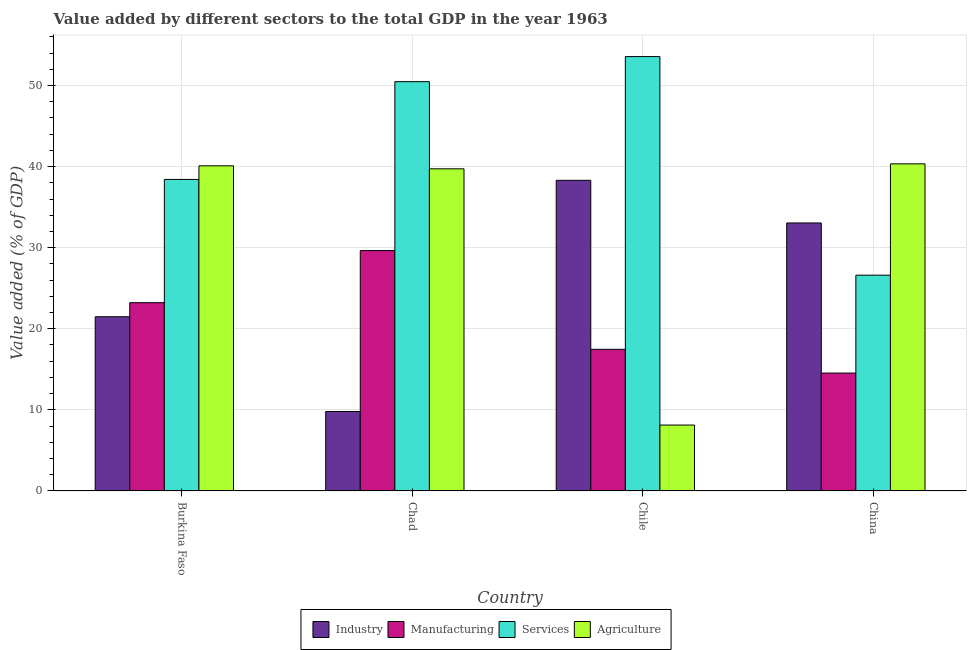How many different coloured bars are there?
Your answer should be very brief. 4. How many bars are there on the 3rd tick from the left?
Keep it short and to the point. 4. What is the label of the 3rd group of bars from the left?
Your answer should be compact. Chile. What is the value added by agricultural sector in Chile?
Provide a succinct answer. 8.13. Across all countries, what is the maximum value added by industrial sector?
Make the answer very short. 38.31. Across all countries, what is the minimum value added by agricultural sector?
Provide a succinct answer. 8.13. In which country was the value added by manufacturing sector maximum?
Make the answer very short. Chad. In which country was the value added by manufacturing sector minimum?
Ensure brevity in your answer.  China. What is the total value added by manufacturing sector in the graph?
Make the answer very short. 84.86. What is the difference between the value added by manufacturing sector in Chile and that in China?
Offer a terse response. 2.93. What is the difference between the value added by agricultural sector in China and the value added by industrial sector in Chile?
Make the answer very short. 2.03. What is the average value added by agricultural sector per country?
Provide a succinct answer. 32.07. What is the difference between the value added by services sector and value added by manufacturing sector in Chad?
Make the answer very short. 20.83. What is the ratio of the value added by industrial sector in Chile to that in China?
Ensure brevity in your answer.  1.16. Is the value added by services sector in Burkina Faso less than that in Chad?
Offer a terse response. Yes. Is the difference between the value added by services sector in Chile and China greater than the difference between the value added by industrial sector in Chile and China?
Provide a succinct answer. Yes. What is the difference between the highest and the second highest value added by manufacturing sector?
Provide a succinct answer. 6.43. What is the difference between the highest and the lowest value added by industrial sector?
Your response must be concise. 28.51. In how many countries, is the value added by services sector greater than the average value added by services sector taken over all countries?
Your answer should be very brief. 2. Is it the case that in every country, the sum of the value added by agricultural sector and value added by manufacturing sector is greater than the sum of value added by industrial sector and value added by services sector?
Provide a succinct answer. No. What does the 2nd bar from the left in Chile represents?
Your answer should be very brief. Manufacturing. What does the 3rd bar from the right in Chile represents?
Keep it short and to the point. Manufacturing. Is it the case that in every country, the sum of the value added by industrial sector and value added by manufacturing sector is greater than the value added by services sector?
Your answer should be compact. No. Are the values on the major ticks of Y-axis written in scientific E-notation?
Your answer should be compact. No. Does the graph contain any zero values?
Ensure brevity in your answer.  No. Does the graph contain grids?
Give a very brief answer. Yes. Where does the legend appear in the graph?
Make the answer very short. Bottom center. How are the legend labels stacked?
Keep it short and to the point. Horizontal. What is the title of the graph?
Your answer should be compact. Value added by different sectors to the total GDP in the year 1963. What is the label or title of the Y-axis?
Offer a very short reply. Value added (% of GDP). What is the Value added (% of GDP) of Industry in Burkina Faso?
Provide a succinct answer. 21.48. What is the Value added (% of GDP) of Manufacturing in Burkina Faso?
Your answer should be compact. 23.22. What is the Value added (% of GDP) of Services in Burkina Faso?
Your answer should be compact. 38.42. What is the Value added (% of GDP) of Agriculture in Burkina Faso?
Ensure brevity in your answer.  40.1. What is the Value added (% of GDP) of Industry in Chad?
Your response must be concise. 9.8. What is the Value added (% of GDP) of Manufacturing in Chad?
Your response must be concise. 29.64. What is the Value added (% of GDP) of Services in Chad?
Offer a very short reply. 50.47. What is the Value added (% of GDP) in Agriculture in Chad?
Offer a terse response. 39.73. What is the Value added (% of GDP) of Industry in Chile?
Provide a short and direct response. 38.31. What is the Value added (% of GDP) of Manufacturing in Chile?
Keep it short and to the point. 17.47. What is the Value added (% of GDP) of Services in Chile?
Keep it short and to the point. 53.57. What is the Value added (% of GDP) of Agriculture in Chile?
Provide a succinct answer. 8.13. What is the Value added (% of GDP) of Industry in China?
Offer a terse response. 33.05. What is the Value added (% of GDP) of Manufacturing in China?
Your response must be concise. 14.54. What is the Value added (% of GDP) in Services in China?
Make the answer very short. 26.61. What is the Value added (% of GDP) of Agriculture in China?
Provide a succinct answer. 40.34. Across all countries, what is the maximum Value added (% of GDP) of Industry?
Your answer should be very brief. 38.31. Across all countries, what is the maximum Value added (% of GDP) of Manufacturing?
Give a very brief answer. 29.64. Across all countries, what is the maximum Value added (% of GDP) of Services?
Your response must be concise. 53.57. Across all countries, what is the maximum Value added (% of GDP) in Agriculture?
Keep it short and to the point. 40.34. Across all countries, what is the minimum Value added (% of GDP) of Industry?
Your answer should be very brief. 9.8. Across all countries, what is the minimum Value added (% of GDP) of Manufacturing?
Offer a terse response. 14.54. Across all countries, what is the minimum Value added (% of GDP) in Services?
Your answer should be compact. 26.61. Across all countries, what is the minimum Value added (% of GDP) of Agriculture?
Provide a succinct answer. 8.13. What is the total Value added (% of GDP) of Industry in the graph?
Provide a succinct answer. 102.64. What is the total Value added (% of GDP) of Manufacturing in the graph?
Provide a succinct answer. 84.86. What is the total Value added (% of GDP) of Services in the graph?
Offer a terse response. 169.07. What is the total Value added (% of GDP) in Agriculture in the graph?
Your answer should be compact. 128.29. What is the difference between the Value added (% of GDP) in Industry in Burkina Faso and that in Chad?
Ensure brevity in your answer.  11.68. What is the difference between the Value added (% of GDP) of Manufacturing in Burkina Faso and that in Chad?
Provide a succinct answer. -6.43. What is the difference between the Value added (% of GDP) of Services in Burkina Faso and that in Chad?
Your answer should be very brief. -12.06. What is the difference between the Value added (% of GDP) in Agriculture in Burkina Faso and that in Chad?
Provide a short and direct response. 0.37. What is the difference between the Value added (% of GDP) of Industry in Burkina Faso and that in Chile?
Provide a short and direct response. -16.82. What is the difference between the Value added (% of GDP) of Manufacturing in Burkina Faso and that in Chile?
Give a very brief answer. 5.75. What is the difference between the Value added (% of GDP) in Services in Burkina Faso and that in Chile?
Your answer should be compact. -15.15. What is the difference between the Value added (% of GDP) of Agriculture in Burkina Faso and that in Chile?
Your response must be concise. 31.97. What is the difference between the Value added (% of GDP) of Industry in Burkina Faso and that in China?
Provide a succinct answer. -11.57. What is the difference between the Value added (% of GDP) in Manufacturing in Burkina Faso and that in China?
Offer a very short reply. 8.68. What is the difference between the Value added (% of GDP) in Services in Burkina Faso and that in China?
Keep it short and to the point. 11.81. What is the difference between the Value added (% of GDP) of Agriculture in Burkina Faso and that in China?
Make the answer very short. -0.24. What is the difference between the Value added (% of GDP) of Industry in Chad and that in Chile?
Ensure brevity in your answer.  -28.51. What is the difference between the Value added (% of GDP) of Manufacturing in Chad and that in Chile?
Give a very brief answer. 12.18. What is the difference between the Value added (% of GDP) of Services in Chad and that in Chile?
Ensure brevity in your answer.  -3.09. What is the difference between the Value added (% of GDP) of Agriculture in Chad and that in Chile?
Make the answer very short. 31.6. What is the difference between the Value added (% of GDP) in Industry in Chad and that in China?
Your answer should be very brief. -23.25. What is the difference between the Value added (% of GDP) in Manufacturing in Chad and that in China?
Your answer should be compact. 15.11. What is the difference between the Value added (% of GDP) of Services in Chad and that in China?
Ensure brevity in your answer.  23.86. What is the difference between the Value added (% of GDP) of Agriculture in Chad and that in China?
Your answer should be compact. -0.61. What is the difference between the Value added (% of GDP) in Industry in Chile and that in China?
Give a very brief answer. 5.26. What is the difference between the Value added (% of GDP) in Manufacturing in Chile and that in China?
Give a very brief answer. 2.93. What is the difference between the Value added (% of GDP) in Services in Chile and that in China?
Your response must be concise. 26.96. What is the difference between the Value added (% of GDP) of Agriculture in Chile and that in China?
Your answer should be compact. -32.21. What is the difference between the Value added (% of GDP) in Industry in Burkina Faso and the Value added (% of GDP) in Manufacturing in Chad?
Keep it short and to the point. -8.16. What is the difference between the Value added (% of GDP) in Industry in Burkina Faso and the Value added (% of GDP) in Services in Chad?
Offer a very short reply. -28.99. What is the difference between the Value added (% of GDP) in Industry in Burkina Faso and the Value added (% of GDP) in Agriculture in Chad?
Give a very brief answer. -18.24. What is the difference between the Value added (% of GDP) of Manufacturing in Burkina Faso and the Value added (% of GDP) of Services in Chad?
Make the answer very short. -27.26. What is the difference between the Value added (% of GDP) in Manufacturing in Burkina Faso and the Value added (% of GDP) in Agriculture in Chad?
Make the answer very short. -16.51. What is the difference between the Value added (% of GDP) of Services in Burkina Faso and the Value added (% of GDP) of Agriculture in Chad?
Your response must be concise. -1.31. What is the difference between the Value added (% of GDP) of Industry in Burkina Faso and the Value added (% of GDP) of Manufacturing in Chile?
Provide a short and direct response. 4.02. What is the difference between the Value added (% of GDP) in Industry in Burkina Faso and the Value added (% of GDP) in Services in Chile?
Offer a terse response. -32.08. What is the difference between the Value added (% of GDP) in Industry in Burkina Faso and the Value added (% of GDP) in Agriculture in Chile?
Your response must be concise. 13.36. What is the difference between the Value added (% of GDP) of Manufacturing in Burkina Faso and the Value added (% of GDP) of Services in Chile?
Ensure brevity in your answer.  -30.35. What is the difference between the Value added (% of GDP) in Manufacturing in Burkina Faso and the Value added (% of GDP) in Agriculture in Chile?
Your answer should be very brief. 15.09. What is the difference between the Value added (% of GDP) in Services in Burkina Faso and the Value added (% of GDP) in Agriculture in Chile?
Make the answer very short. 30.29. What is the difference between the Value added (% of GDP) in Industry in Burkina Faso and the Value added (% of GDP) in Manufacturing in China?
Your answer should be compact. 6.95. What is the difference between the Value added (% of GDP) in Industry in Burkina Faso and the Value added (% of GDP) in Services in China?
Make the answer very short. -5.13. What is the difference between the Value added (% of GDP) in Industry in Burkina Faso and the Value added (% of GDP) in Agriculture in China?
Give a very brief answer. -18.86. What is the difference between the Value added (% of GDP) of Manufacturing in Burkina Faso and the Value added (% of GDP) of Services in China?
Make the answer very short. -3.39. What is the difference between the Value added (% of GDP) of Manufacturing in Burkina Faso and the Value added (% of GDP) of Agriculture in China?
Ensure brevity in your answer.  -17.12. What is the difference between the Value added (% of GDP) of Services in Burkina Faso and the Value added (% of GDP) of Agriculture in China?
Provide a short and direct response. -1.92. What is the difference between the Value added (% of GDP) of Industry in Chad and the Value added (% of GDP) of Manufacturing in Chile?
Offer a terse response. -7.67. What is the difference between the Value added (% of GDP) in Industry in Chad and the Value added (% of GDP) in Services in Chile?
Give a very brief answer. -43.77. What is the difference between the Value added (% of GDP) in Industry in Chad and the Value added (% of GDP) in Agriculture in Chile?
Ensure brevity in your answer.  1.67. What is the difference between the Value added (% of GDP) of Manufacturing in Chad and the Value added (% of GDP) of Services in Chile?
Make the answer very short. -23.92. What is the difference between the Value added (% of GDP) in Manufacturing in Chad and the Value added (% of GDP) in Agriculture in Chile?
Offer a very short reply. 21.52. What is the difference between the Value added (% of GDP) in Services in Chad and the Value added (% of GDP) in Agriculture in Chile?
Your answer should be very brief. 42.35. What is the difference between the Value added (% of GDP) of Industry in Chad and the Value added (% of GDP) of Manufacturing in China?
Provide a succinct answer. -4.74. What is the difference between the Value added (% of GDP) in Industry in Chad and the Value added (% of GDP) in Services in China?
Make the answer very short. -16.81. What is the difference between the Value added (% of GDP) of Industry in Chad and the Value added (% of GDP) of Agriculture in China?
Give a very brief answer. -30.54. What is the difference between the Value added (% of GDP) of Manufacturing in Chad and the Value added (% of GDP) of Services in China?
Provide a short and direct response. 3.03. What is the difference between the Value added (% of GDP) of Manufacturing in Chad and the Value added (% of GDP) of Agriculture in China?
Your response must be concise. -10.69. What is the difference between the Value added (% of GDP) of Services in Chad and the Value added (% of GDP) of Agriculture in China?
Provide a short and direct response. 10.14. What is the difference between the Value added (% of GDP) in Industry in Chile and the Value added (% of GDP) in Manufacturing in China?
Make the answer very short. 23.77. What is the difference between the Value added (% of GDP) of Industry in Chile and the Value added (% of GDP) of Services in China?
Ensure brevity in your answer.  11.7. What is the difference between the Value added (% of GDP) in Industry in Chile and the Value added (% of GDP) in Agriculture in China?
Your response must be concise. -2.03. What is the difference between the Value added (% of GDP) in Manufacturing in Chile and the Value added (% of GDP) in Services in China?
Ensure brevity in your answer.  -9.15. What is the difference between the Value added (% of GDP) in Manufacturing in Chile and the Value added (% of GDP) in Agriculture in China?
Your answer should be very brief. -22.87. What is the difference between the Value added (% of GDP) in Services in Chile and the Value added (% of GDP) in Agriculture in China?
Provide a short and direct response. 13.23. What is the average Value added (% of GDP) of Industry per country?
Your answer should be compact. 25.66. What is the average Value added (% of GDP) of Manufacturing per country?
Provide a short and direct response. 21.22. What is the average Value added (% of GDP) in Services per country?
Your answer should be very brief. 42.27. What is the average Value added (% of GDP) in Agriculture per country?
Make the answer very short. 32.07. What is the difference between the Value added (% of GDP) of Industry and Value added (% of GDP) of Manufacturing in Burkina Faso?
Give a very brief answer. -1.73. What is the difference between the Value added (% of GDP) in Industry and Value added (% of GDP) in Services in Burkina Faso?
Your answer should be very brief. -16.93. What is the difference between the Value added (% of GDP) in Industry and Value added (% of GDP) in Agriculture in Burkina Faso?
Keep it short and to the point. -18.61. What is the difference between the Value added (% of GDP) in Manufacturing and Value added (% of GDP) in Services in Burkina Faso?
Provide a short and direct response. -15.2. What is the difference between the Value added (% of GDP) of Manufacturing and Value added (% of GDP) of Agriculture in Burkina Faso?
Your response must be concise. -16.88. What is the difference between the Value added (% of GDP) of Services and Value added (% of GDP) of Agriculture in Burkina Faso?
Offer a very short reply. -1.68. What is the difference between the Value added (% of GDP) in Industry and Value added (% of GDP) in Manufacturing in Chad?
Keep it short and to the point. -19.84. What is the difference between the Value added (% of GDP) in Industry and Value added (% of GDP) in Services in Chad?
Offer a terse response. -40.68. What is the difference between the Value added (% of GDP) in Industry and Value added (% of GDP) in Agriculture in Chad?
Your answer should be compact. -29.93. What is the difference between the Value added (% of GDP) in Manufacturing and Value added (% of GDP) in Services in Chad?
Your answer should be compact. -20.83. What is the difference between the Value added (% of GDP) in Manufacturing and Value added (% of GDP) in Agriculture in Chad?
Offer a terse response. -10.08. What is the difference between the Value added (% of GDP) in Services and Value added (% of GDP) in Agriculture in Chad?
Your answer should be compact. 10.75. What is the difference between the Value added (% of GDP) in Industry and Value added (% of GDP) in Manufacturing in Chile?
Ensure brevity in your answer.  20.84. What is the difference between the Value added (% of GDP) in Industry and Value added (% of GDP) in Services in Chile?
Provide a succinct answer. -15.26. What is the difference between the Value added (% of GDP) in Industry and Value added (% of GDP) in Agriculture in Chile?
Your answer should be very brief. 30.18. What is the difference between the Value added (% of GDP) of Manufacturing and Value added (% of GDP) of Services in Chile?
Offer a terse response. -36.1. What is the difference between the Value added (% of GDP) of Manufacturing and Value added (% of GDP) of Agriculture in Chile?
Your answer should be compact. 9.34. What is the difference between the Value added (% of GDP) of Services and Value added (% of GDP) of Agriculture in Chile?
Give a very brief answer. 45.44. What is the difference between the Value added (% of GDP) in Industry and Value added (% of GDP) in Manufacturing in China?
Provide a short and direct response. 18.51. What is the difference between the Value added (% of GDP) of Industry and Value added (% of GDP) of Services in China?
Provide a short and direct response. 6.44. What is the difference between the Value added (% of GDP) of Industry and Value added (% of GDP) of Agriculture in China?
Provide a short and direct response. -7.29. What is the difference between the Value added (% of GDP) of Manufacturing and Value added (% of GDP) of Services in China?
Provide a short and direct response. -12.07. What is the difference between the Value added (% of GDP) in Manufacturing and Value added (% of GDP) in Agriculture in China?
Offer a terse response. -25.8. What is the difference between the Value added (% of GDP) in Services and Value added (% of GDP) in Agriculture in China?
Your answer should be very brief. -13.73. What is the ratio of the Value added (% of GDP) in Industry in Burkina Faso to that in Chad?
Your response must be concise. 2.19. What is the ratio of the Value added (% of GDP) in Manufacturing in Burkina Faso to that in Chad?
Your answer should be compact. 0.78. What is the ratio of the Value added (% of GDP) in Services in Burkina Faso to that in Chad?
Give a very brief answer. 0.76. What is the ratio of the Value added (% of GDP) of Agriculture in Burkina Faso to that in Chad?
Offer a very short reply. 1.01. What is the ratio of the Value added (% of GDP) of Industry in Burkina Faso to that in Chile?
Ensure brevity in your answer.  0.56. What is the ratio of the Value added (% of GDP) in Manufacturing in Burkina Faso to that in Chile?
Ensure brevity in your answer.  1.33. What is the ratio of the Value added (% of GDP) in Services in Burkina Faso to that in Chile?
Your answer should be very brief. 0.72. What is the ratio of the Value added (% of GDP) in Agriculture in Burkina Faso to that in Chile?
Provide a succinct answer. 4.93. What is the ratio of the Value added (% of GDP) of Industry in Burkina Faso to that in China?
Your response must be concise. 0.65. What is the ratio of the Value added (% of GDP) in Manufacturing in Burkina Faso to that in China?
Ensure brevity in your answer.  1.6. What is the ratio of the Value added (% of GDP) of Services in Burkina Faso to that in China?
Your answer should be very brief. 1.44. What is the ratio of the Value added (% of GDP) in Agriculture in Burkina Faso to that in China?
Ensure brevity in your answer.  0.99. What is the ratio of the Value added (% of GDP) of Industry in Chad to that in Chile?
Offer a terse response. 0.26. What is the ratio of the Value added (% of GDP) of Manufacturing in Chad to that in Chile?
Provide a succinct answer. 1.7. What is the ratio of the Value added (% of GDP) in Services in Chad to that in Chile?
Your answer should be very brief. 0.94. What is the ratio of the Value added (% of GDP) of Agriculture in Chad to that in Chile?
Your answer should be very brief. 4.89. What is the ratio of the Value added (% of GDP) in Industry in Chad to that in China?
Your answer should be compact. 0.3. What is the ratio of the Value added (% of GDP) in Manufacturing in Chad to that in China?
Your answer should be compact. 2.04. What is the ratio of the Value added (% of GDP) in Services in Chad to that in China?
Offer a terse response. 1.9. What is the ratio of the Value added (% of GDP) of Industry in Chile to that in China?
Offer a terse response. 1.16. What is the ratio of the Value added (% of GDP) of Manufacturing in Chile to that in China?
Your answer should be compact. 1.2. What is the ratio of the Value added (% of GDP) of Services in Chile to that in China?
Provide a short and direct response. 2.01. What is the ratio of the Value added (% of GDP) in Agriculture in Chile to that in China?
Offer a very short reply. 0.2. What is the difference between the highest and the second highest Value added (% of GDP) of Industry?
Your answer should be compact. 5.26. What is the difference between the highest and the second highest Value added (% of GDP) in Manufacturing?
Make the answer very short. 6.43. What is the difference between the highest and the second highest Value added (% of GDP) of Services?
Your answer should be compact. 3.09. What is the difference between the highest and the second highest Value added (% of GDP) in Agriculture?
Provide a succinct answer. 0.24. What is the difference between the highest and the lowest Value added (% of GDP) in Industry?
Provide a short and direct response. 28.51. What is the difference between the highest and the lowest Value added (% of GDP) in Manufacturing?
Ensure brevity in your answer.  15.11. What is the difference between the highest and the lowest Value added (% of GDP) in Services?
Make the answer very short. 26.96. What is the difference between the highest and the lowest Value added (% of GDP) of Agriculture?
Offer a terse response. 32.21. 